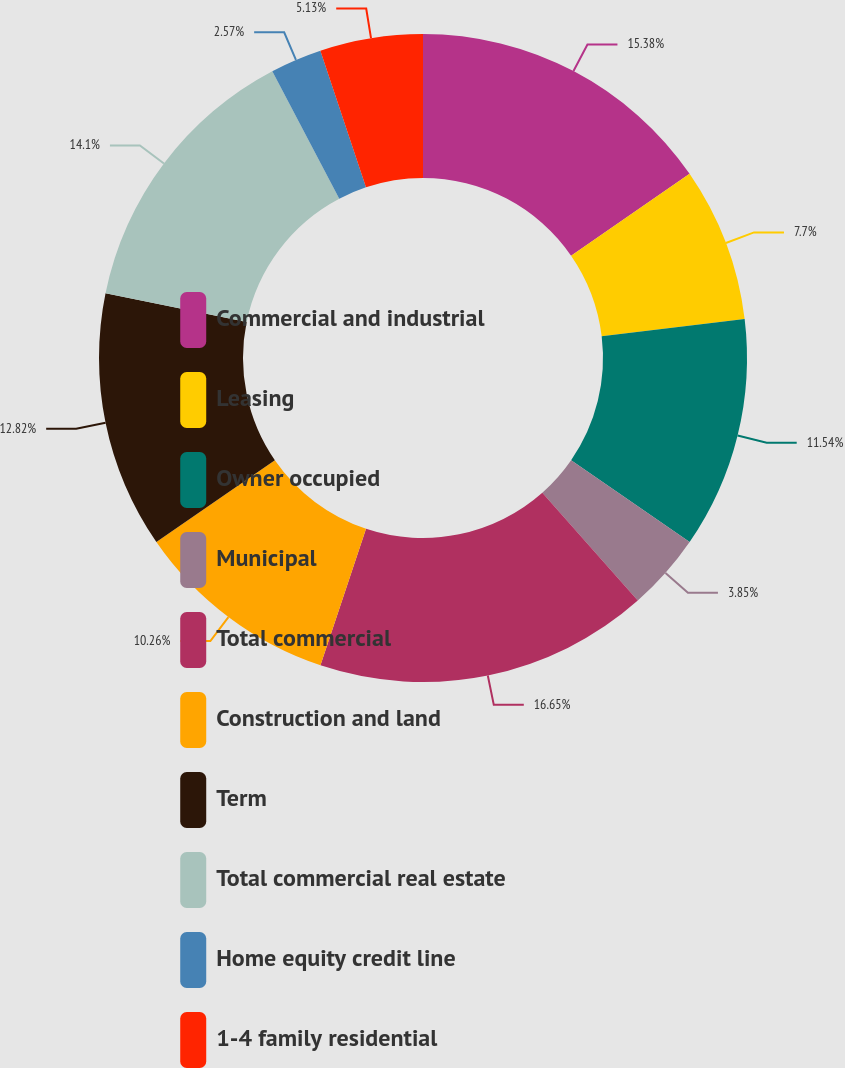Convert chart. <chart><loc_0><loc_0><loc_500><loc_500><pie_chart><fcel>Commercial and industrial<fcel>Leasing<fcel>Owner occupied<fcel>Municipal<fcel>Total commercial<fcel>Construction and land<fcel>Term<fcel>Total commercial real estate<fcel>Home equity credit line<fcel>1-4 family residential<nl><fcel>15.38%<fcel>7.7%<fcel>11.54%<fcel>3.85%<fcel>16.66%<fcel>10.26%<fcel>12.82%<fcel>14.1%<fcel>2.57%<fcel>5.13%<nl></chart> 